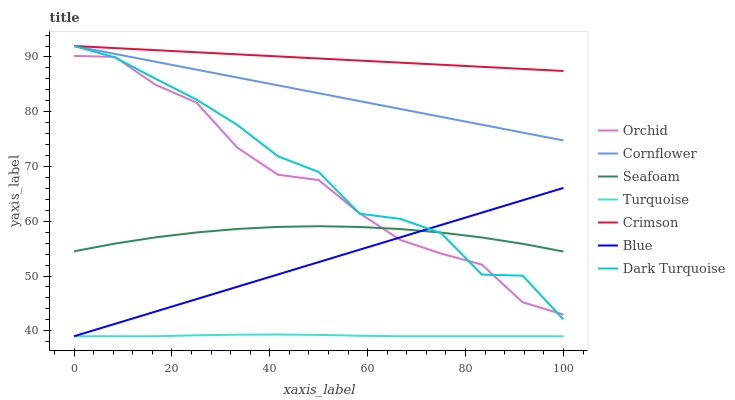Does Turquoise have the minimum area under the curve?
Answer yes or no. Yes. Does Crimson have the maximum area under the curve?
Answer yes or no. Yes. Does Cornflower have the minimum area under the curve?
Answer yes or no. No. Does Cornflower have the maximum area under the curve?
Answer yes or no. No. Is Blue the smoothest?
Answer yes or no. Yes. Is Dark Turquoise the roughest?
Answer yes or no. Yes. Is Cornflower the smoothest?
Answer yes or no. No. Is Cornflower the roughest?
Answer yes or no. No. Does Blue have the lowest value?
Answer yes or no. Yes. Does Cornflower have the lowest value?
Answer yes or no. No. Does Crimson have the highest value?
Answer yes or no. Yes. Does Turquoise have the highest value?
Answer yes or no. No. Is Blue less than Crimson?
Answer yes or no. Yes. Is Crimson greater than Orchid?
Answer yes or no. Yes. Does Turquoise intersect Blue?
Answer yes or no. Yes. Is Turquoise less than Blue?
Answer yes or no. No. Is Turquoise greater than Blue?
Answer yes or no. No. Does Blue intersect Crimson?
Answer yes or no. No. 